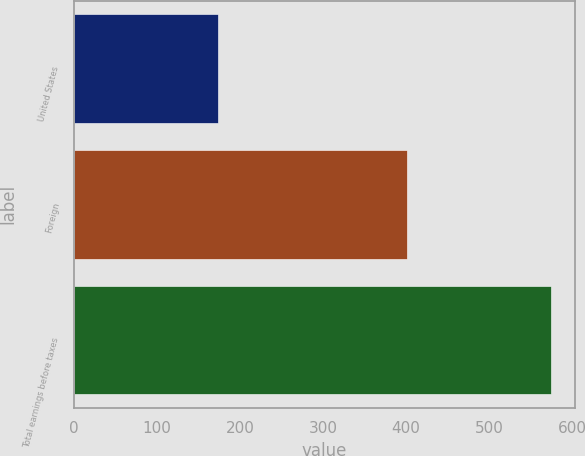Convert chart. <chart><loc_0><loc_0><loc_500><loc_500><bar_chart><fcel>United States<fcel>Foreign<fcel>Total earnings before taxes<nl><fcel>173.9<fcel>400.6<fcel>574.5<nl></chart> 